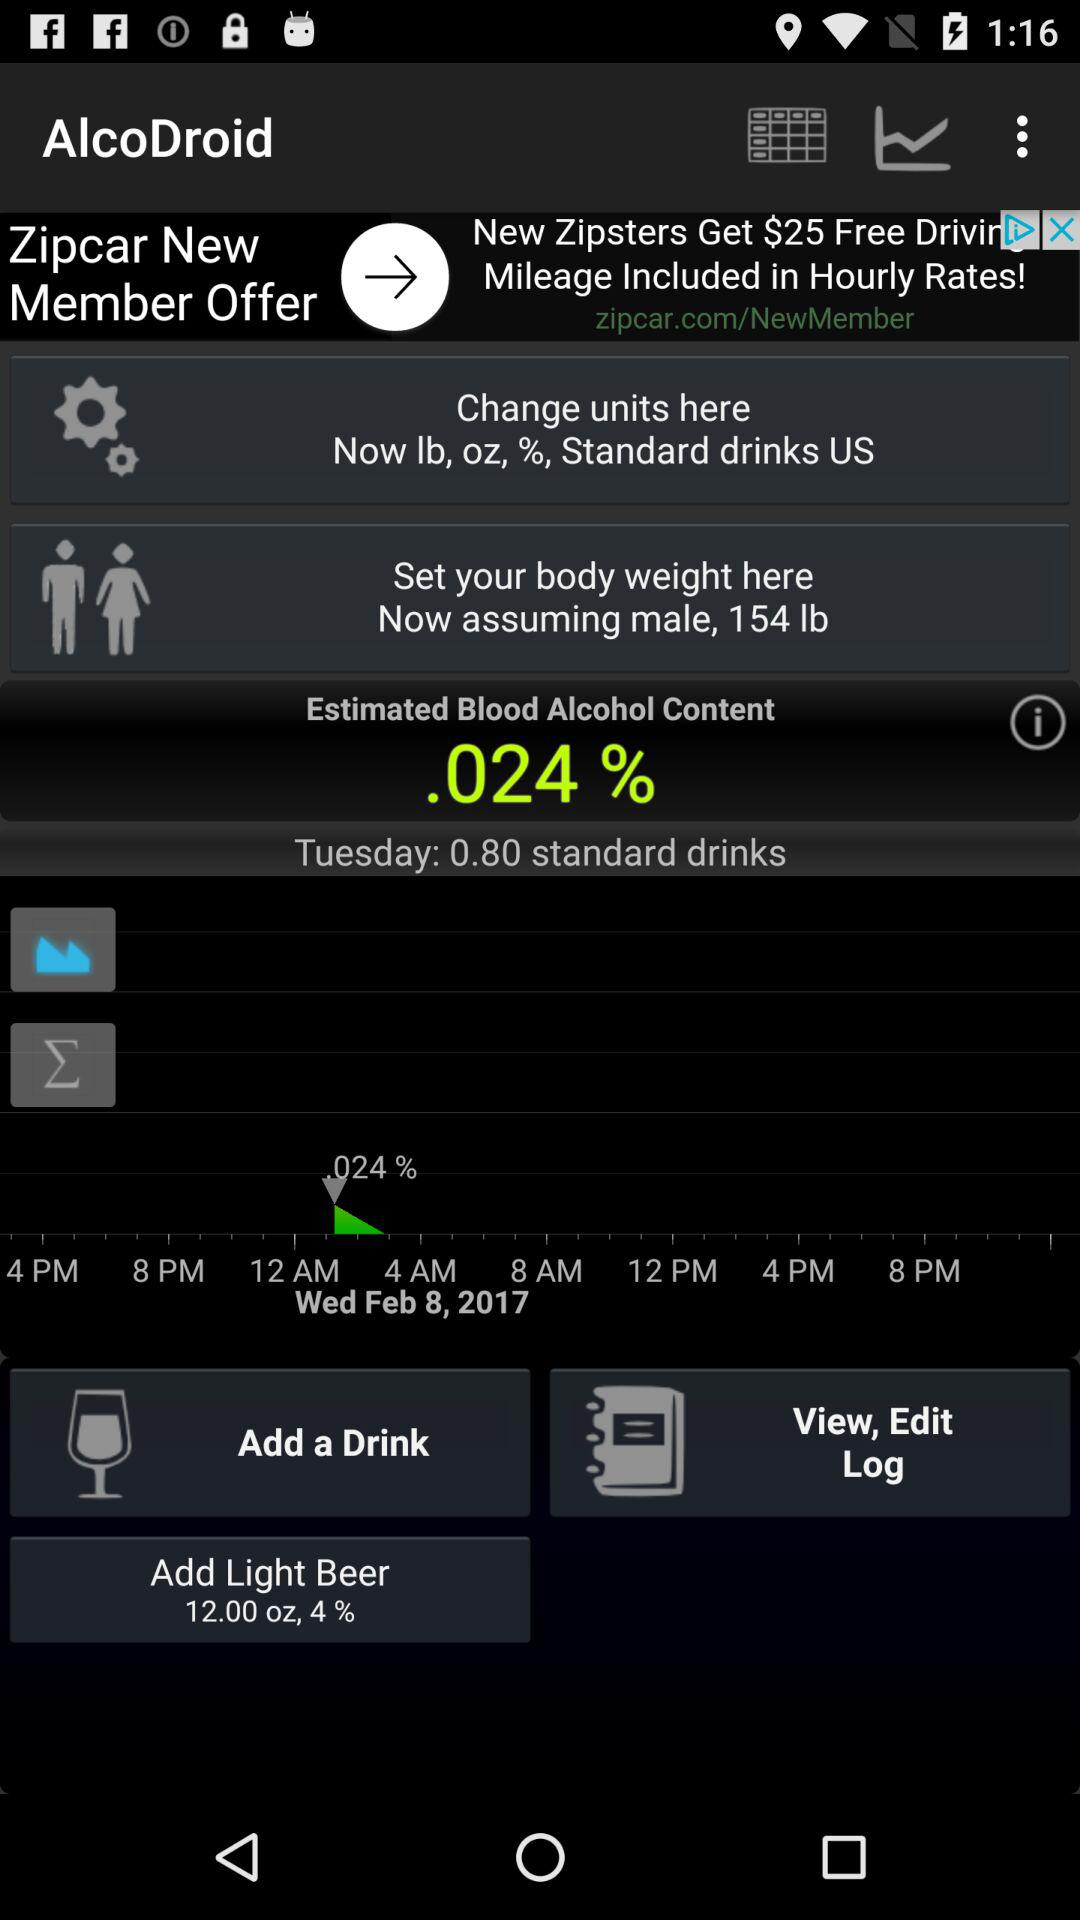What is the assumed weight for a male? The assumed weight for a male is 154 lbs. 